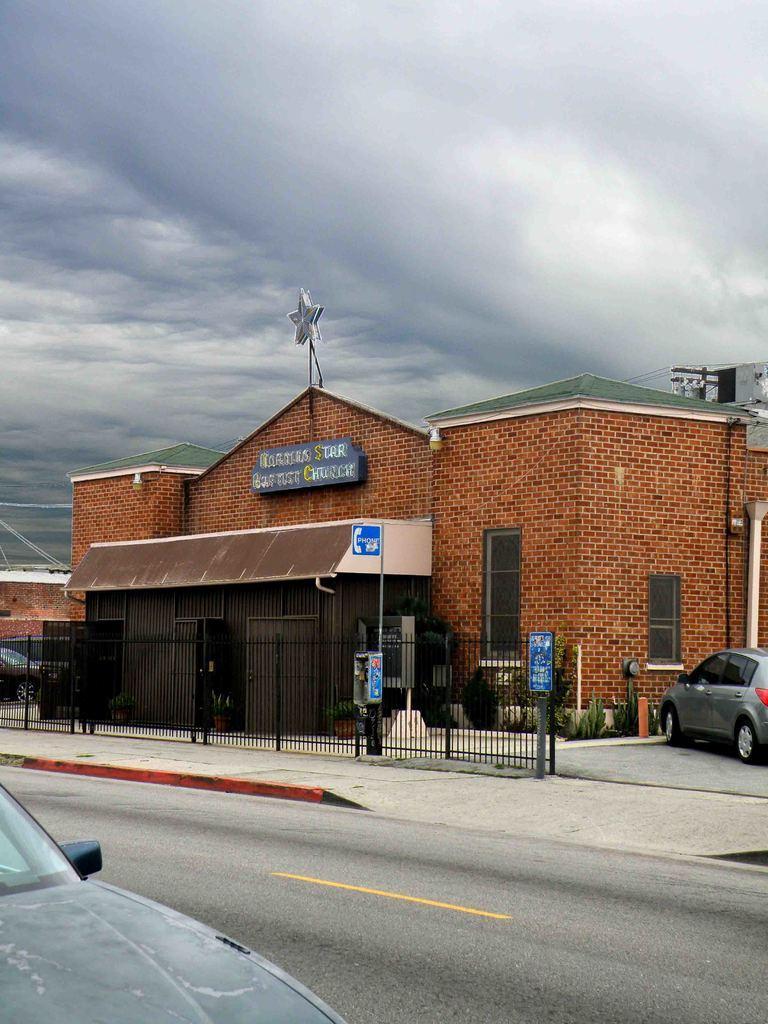Please provide a concise description of this image. In this image we can see road, two vehicles and in the background of the image there is footpath, fencing, house and top of the image there is cloudy sky. 